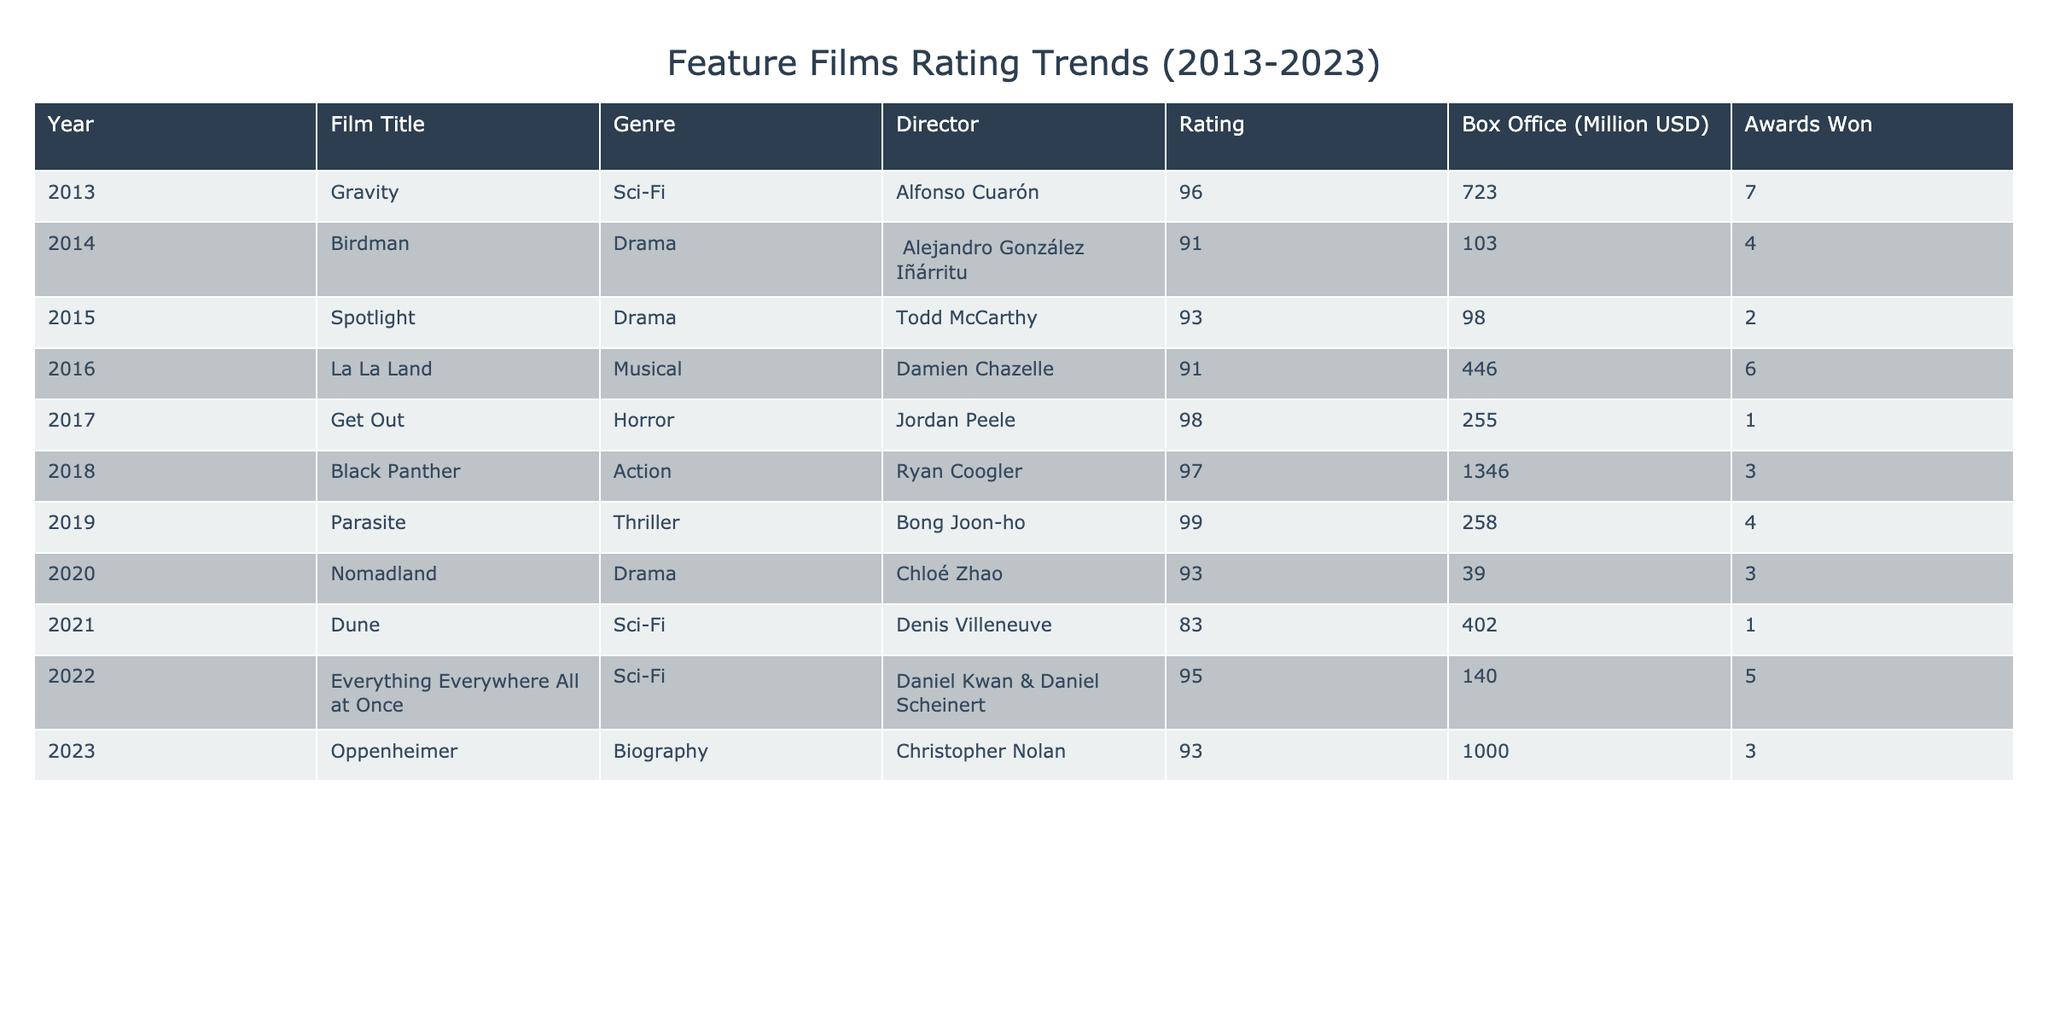What is the highest rating achieved by a film in this table? Looking at the Ratings column, "Parasite" has the highest rating of 99.
Answer: 99 Which film won the most awards and how many did it win? "Gravity" won the most awards with a total of 7.
Answer: 7 What is the average box office collection of films in this dataset? To calculate the average, I sum the Box Office values: 723 + 103 + 98 + 446 + 255 + 1346 + 258 + 39 + 402 + 1000 = 3370. There are 10 films, so the average is 3370 / 10 = 337.
Answer: 337 Did any film released in 2021 win more than 2 awards? The only film from 2021 is "Dune," which won 1 award. Therefore, no films from that year won more than 2 awards.
Answer: No Which genre has the highest average rating across the films? Calculate average ratings for each genre: Sci-Fi averages (96 + 83 + 95) / 3 = 91.33; Drama averages (91 + 93 + 93) / 3 = 92.33; Horror is (98) = 98; etc. The calculations show that Horror has the highest average rating of 98.
Answer: Horror How many films had a rating of 90 or above? Referring to the Ratings column, the films with ratings of 90 or above are: Gravity, Birdman, Spotlight, La La Land, Get Out, Black Panther, Parasite, Nomadland, Everything Everywhere All at Once, and Oppenheimer, making it a total of 10 films.
Answer: 10 In which year was the film "Oppenheimer" released? The film "Oppenheimer" is listed in the table under the year 2023.
Answer: 2023 What is the difference in box office collection between the highest and lowest earning film? The highest box office collection is "Black Panther" with 1346 million, and the lowest is "Nomadland" with 39 million. The difference is 1346 - 39 = 1307 million.
Answer: 1307 Which film directed by a woman has the highest rating and what is that rating? The film directed by a woman is "Nomadland" by Chloé Zhao, which has a rating of 93.
Answer: 93 